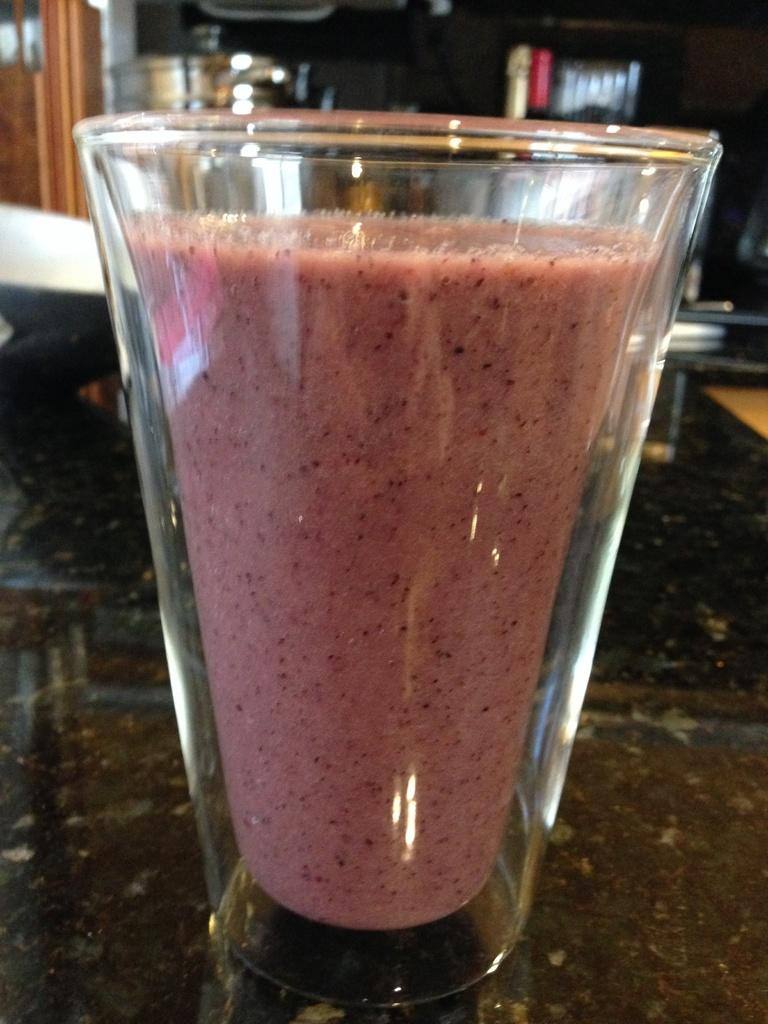What is in the transparent glass that is visible in the image? There is juice in a transparent glass in the image. Where is the glass located in the image? The glass is on a table in the image. What type of location is the image taken in? The image was taken inside a room. What objects are visible behind the glass? There is a vessel and a bowl behind the glass in the image. What type of toys can be seen in the image? There are no toys present in the image. What color is the paint on the wall behind the glass? There is no paint visible on the wall behind the glass in the image. 